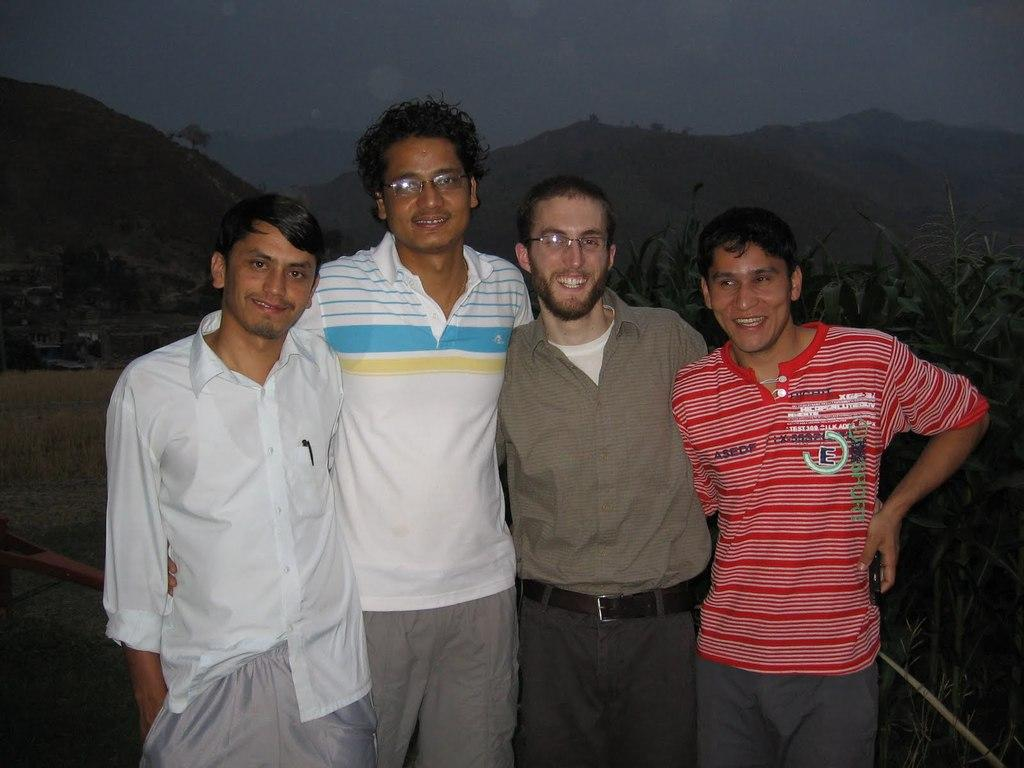What can be seen in the foreground of the image? There are persons standing in the front of the image. What is the facial expression of the persons in the image? The persons are smiling. What type of natural scenery is visible in the background of the image? There are plants and mountains in the background of the image. What is the condition of the ground in the image? Dry grass is present on the ground. How many stems can be seen on the horses in the image? There are no horses present in the image, so there are no stems to count. What type of ants can be seen crawling on the plants in the image? There are no ants visible in the image; only plants and mountains can be seen in the background. 